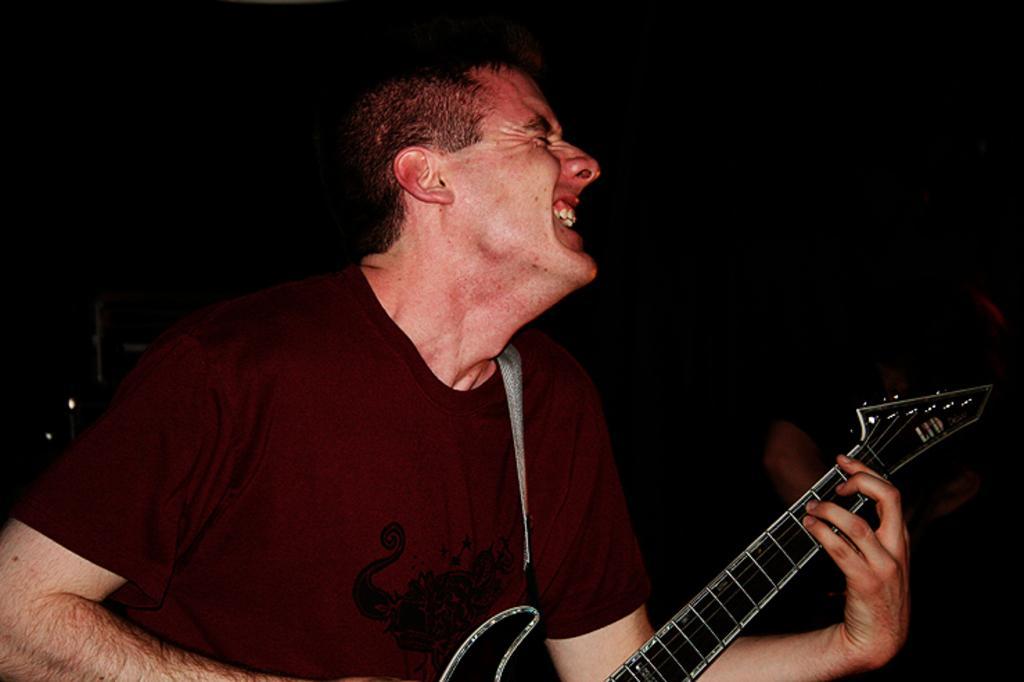Could you give a brief overview of what you see in this image? Here a man is playing the guitar and also he is wearing a T-Shirt. 